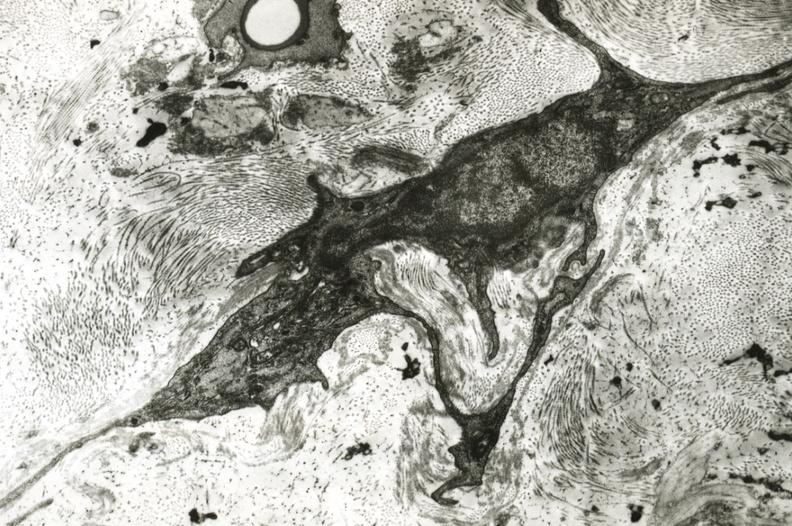s cranial artery present?
Answer the question using a single word or phrase. Yes 